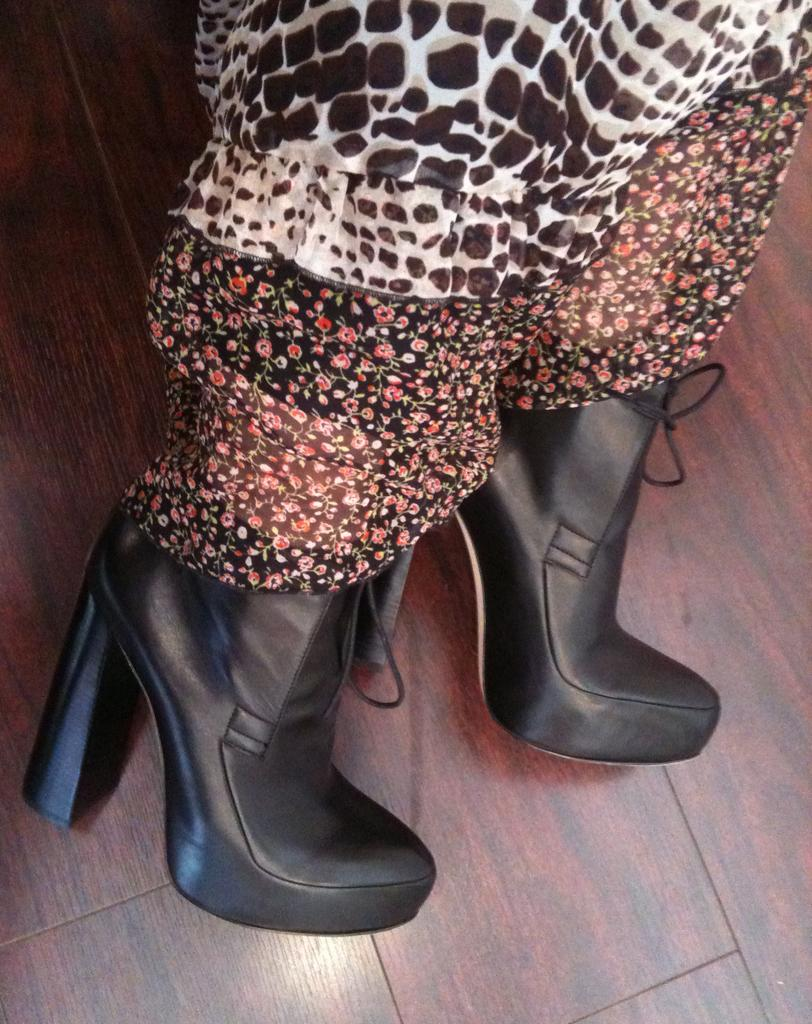What objects are in the image? There are shoes in the image. To whom do the shoes belong? The shoes belong to a person. What type of flooring is visible at the bottom of the image? There is a wooden floor at the bottom of the image. What type of clocks can be seen hanging on the wall in the image? There are no clocks visible in the image; it only features shoes and a wooden floor. 